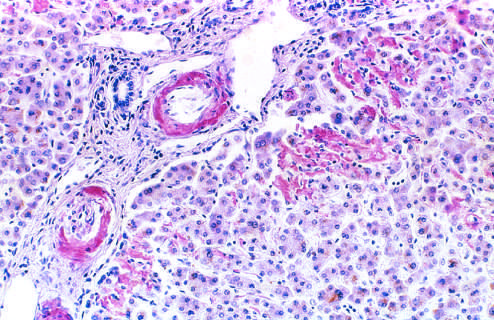what does a section of liver stained with congo red reveal in the walls of blood vessels and along sinusoids?
Answer the question using a single word or phrase. Pink-red deposits amyloid 